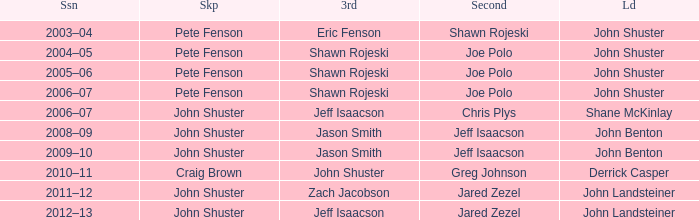Who was the lead with John Shuster as skip in the season of 2009–10? John Benton. 